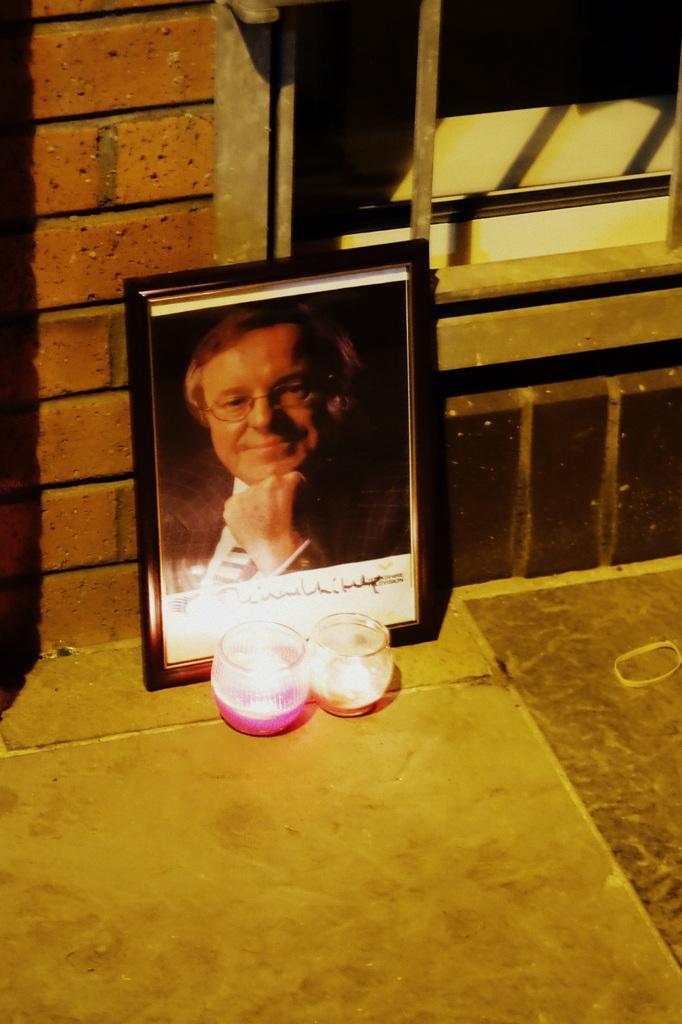Could you give a brief overview of what you see in this image? In this image we can see a photo frame. In the frame we can see an image of a person and some text. In front of the photo there are two glasses. In the background, we can see a wall and a window. 